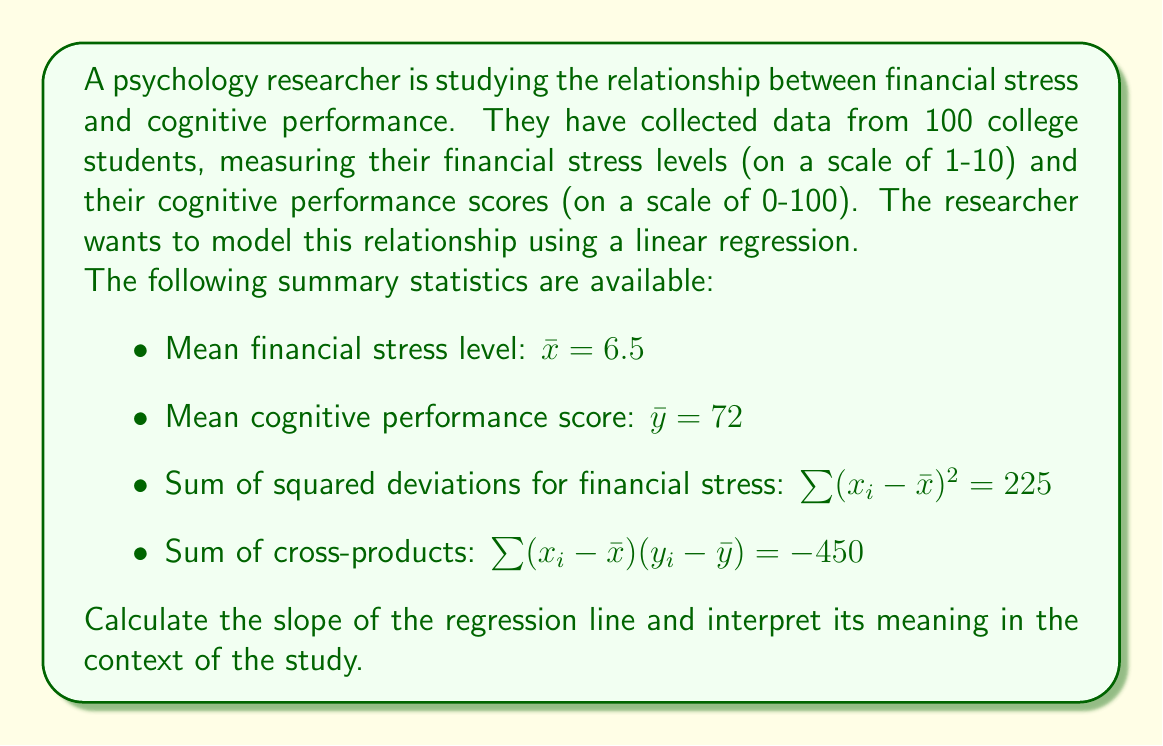What is the answer to this math problem? Let's approach this step-by-step:

1) The linear regression equation is of the form $y = mx + b$, where $m$ is the slope and $b$ is the y-intercept.

2) To find the slope $m$, we use the formula:

   $$m = \frac{\sum (x_i - \bar{x})(y_i - \bar{y})}{\sum (x_i - \bar{x})^2}$$

3) We are given:
   $\sum (x_i - \bar{x})(y_i - \bar{y}) = -450$
   $\sum (x_i - \bar{x})^2 = 225$

4) Substituting these values:

   $$m = \frac{-450}{225} = -2$$

5) Therefore, the slope of the regression line is -2.

Interpretation:
The slope of -2 indicates that for every 1-point increase in financial stress level, the cognitive performance score is expected to decrease by 2 points, on average.

This negative relationship suggests that higher levels of financial stress are associated with lower cognitive performance among the college students in the study.
Answer: $m = -2$; For each 1-point increase in financial stress, cognitive performance decreases by 2 points on average. 